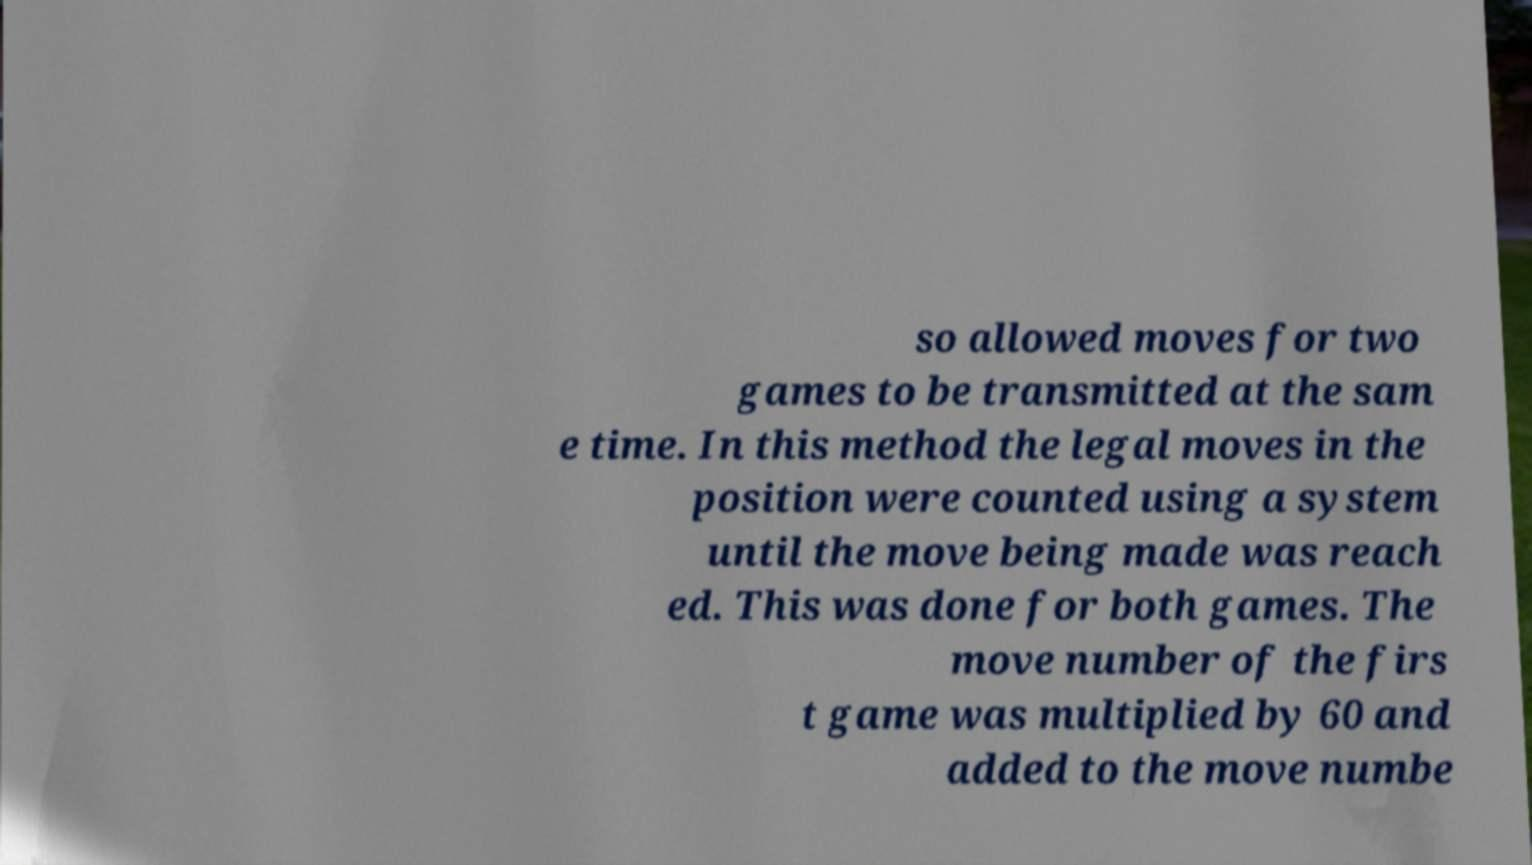Please identify and transcribe the text found in this image. so allowed moves for two games to be transmitted at the sam e time. In this method the legal moves in the position were counted using a system until the move being made was reach ed. This was done for both games. The move number of the firs t game was multiplied by 60 and added to the move numbe 